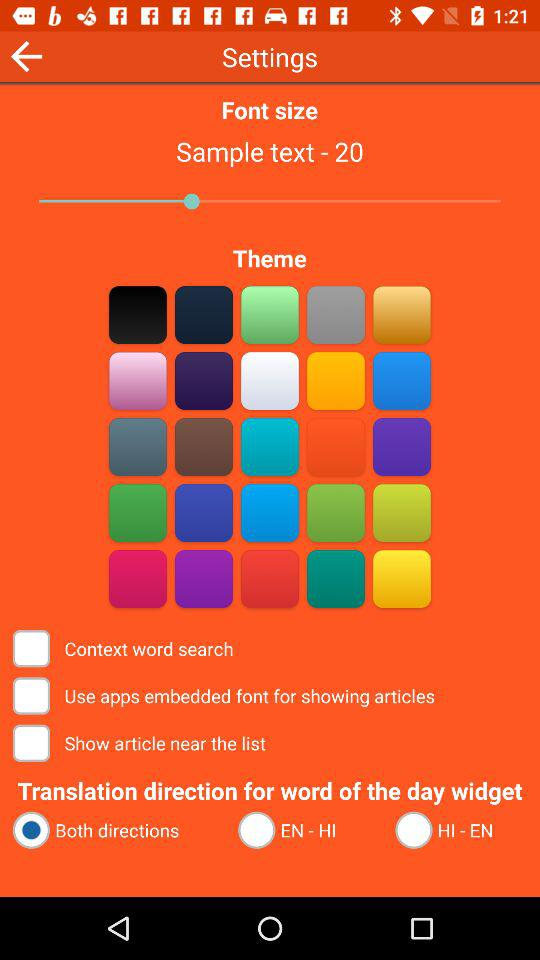What is the selected font size? The selected font size is 20. 